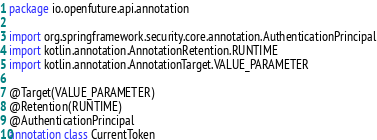<code> <loc_0><loc_0><loc_500><loc_500><_Kotlin_>package io.openfuture.api.annotation

import org.springframework.security.core.annotation.AuthenticationPrincipal
import kotlin.annotation.AnnotationRetention.RUNTIME
import kotlin.annotation.AnnotationTarget.VALUE_PARAMETER

@Target(VALUE_PARAMETER)
@Retention(RUNTIME)
@AuthenticationPrincipal
annotation class CurrentToken</code> 